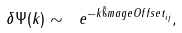Convert formula to latex. <formula><loc_0><loc_0><loc_500><loc_500>\delta \Psi ( k ) \sim \ e ^ { - k { \tilde { \i } m a g e O f f s e t } _ { i j } } ,</formula> 